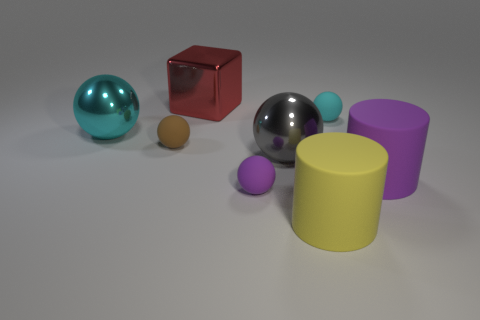There is a large red thing; is its shape the same as the big object to the left of the big red metal object?
Provide a succinct answer. No. What material is the big gray thing?
Offer a terse response. Metal. What size is the brown object that is the same shape as the cyan metal object?
Your answer should be very brief. Small. What number of other things are made of the same material as the tiny cyan object?
Make the answer very short. 4. Does the yellow object have the same material as the red block that is on the left side of the purple cylinder?
Keep it short and to the point. No. Are there fewer big cyan spheres to the left of the cyan metallic object than metal cubes in front of the red metal thing?
Offer a very short reply. No. What color is the small rubber thing that is on the right side of the gray object?
Provide a short and direct response. Cyan. Is the size of the cylinder right of the yellow rubber thing the same as the big gray metal object?
Offer a very short reply. Yes. How many spheres are behind the brown ball?
Your answer should be very brief. 2. Is there a cyan shiny block that has the same size as the purple ball?
Offer a very short reply. No. 